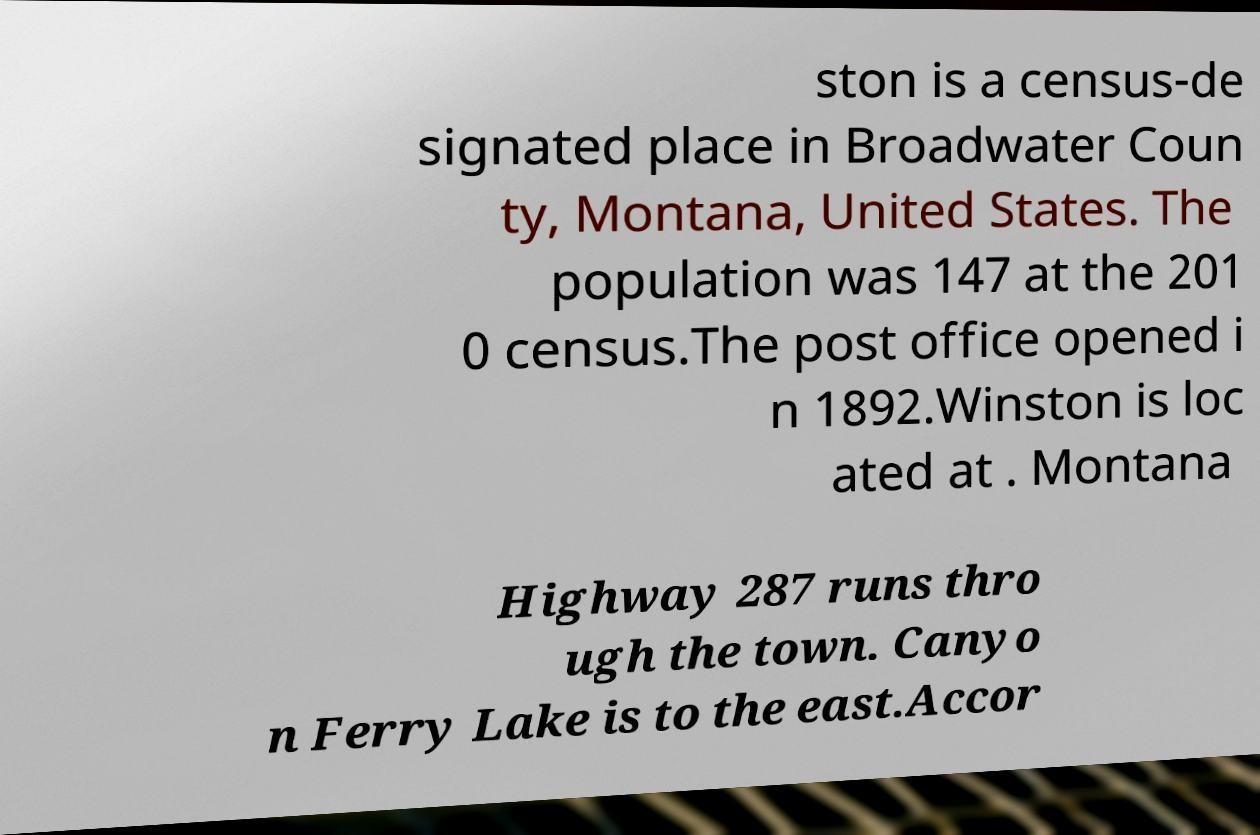There's text embedded in this image that I need extracted. Can you transcribe it verbatim? ston is a census-de signated place in Broadwater Coun ty, Montana, United States. The population was 147 at the 201 0 census.The post office opened i n 1892.Winston is loc ated at . Montana Highway 287 runs thro ugh the town. Canyo n Ferry Lake is to the east.Accor 